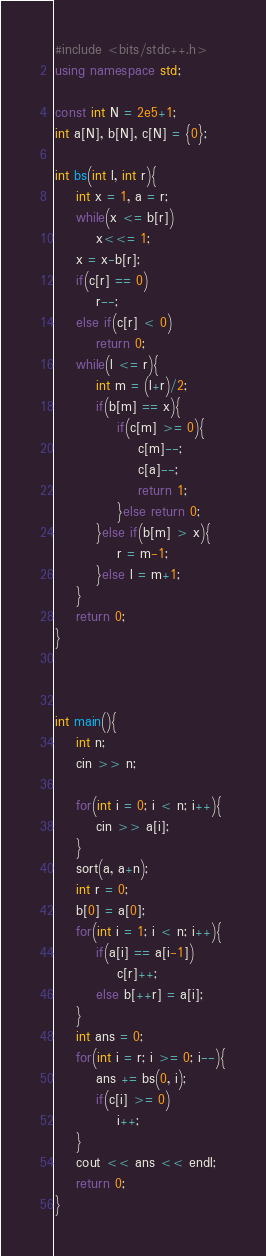Convert code to text. <code><loc_0><loc_0><loc_500><loc_500><_C++_>#include <bits/stdc++.h>
using namespace std;

const int N = 2e5+1;
int a[N], b[N], c[N] = {0};

int bs(int l, int r){
	int x = 1, a = r;
	while(x <= b[r])
		x<<= 1;
	x = x-b[r];
	if(c[r] == 0)
		r--;
	else if(c[r] < 0)
		return 0;
	while(l <= r){
		int m = (l+r)/2;
		if(b[m] == x){
			if(c[m] >= 0){
				c[m]--;
				c[a]--;
				return 1;
			}else return 0;
		}else if(b[m] > x){
			r = m-1;
		}else l = m+1;
	}
	return 0;
}



int main(){
	int n;
	cin >> n;

	for(int i = 0; i < n; i++){
		cin >> a[i];
	}
	sort(a, a+n);
	int r = 0;
	b[0] = a[0];
	for(int i = 1; i < n; i++){
		if(a[i] == a[i-1])
			c[r]++;
		else b[++r] = a[i];
	}
	int ans = 0;
	for(int i = r; i >= 0; i--){
		ans += bs(0, i);
		if(c[i] >= 0)
			i++;
	}
	cout << ans << endl;
	return 0;
}
</code> 